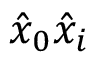Convert formula to latex. <formula><loc_0><loc_0><loc_500><loc_500>\hat { x } _ { 0 } \hat { x } _ { i }</formula> 